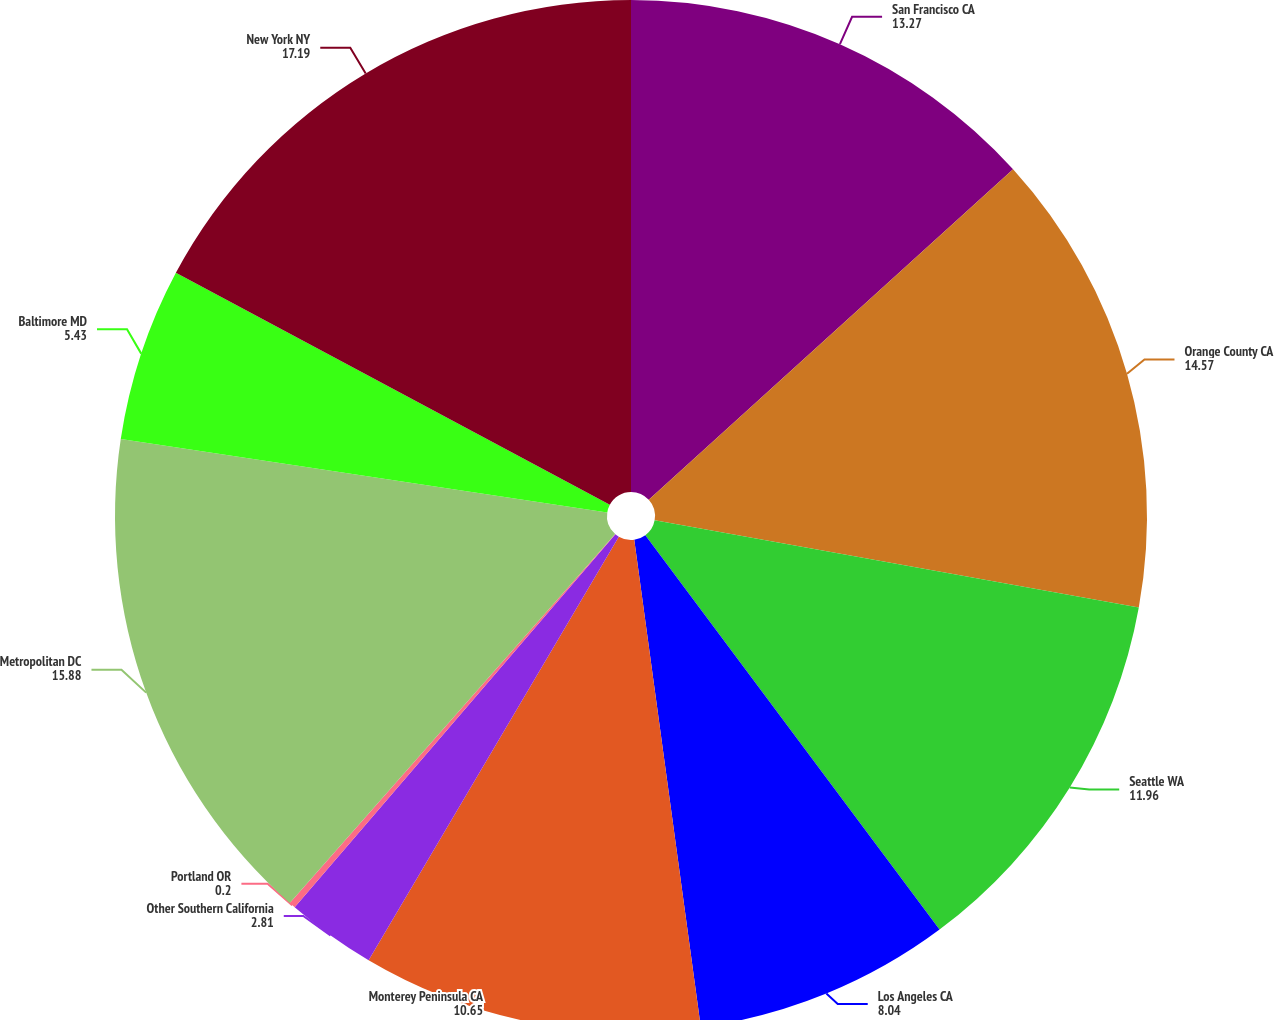Convert chart. <chart><loc_0><loc_0><loc_500><loc_500><pie_chart><fcel>San Francisco CA<fcel>Orange County CA<fcel>Seattle WA<fcel>Los Angeles CA<fcel>Monterey Peninsula CA<fcel>Other Southern California<fcel>Portland OR<fcel>Metropolitan DC<fcel>Baltimore MD<fcel>New York NY<nl><fcel>13.27%<fcel>14.57%<fcel>11.96%<fcel>8.04%<fcel>10.65%<fcel>2.81%<fcel>0.2%<fcel>15.88%<fcel>5.43%<fcel>17.19%<nl></chart> 